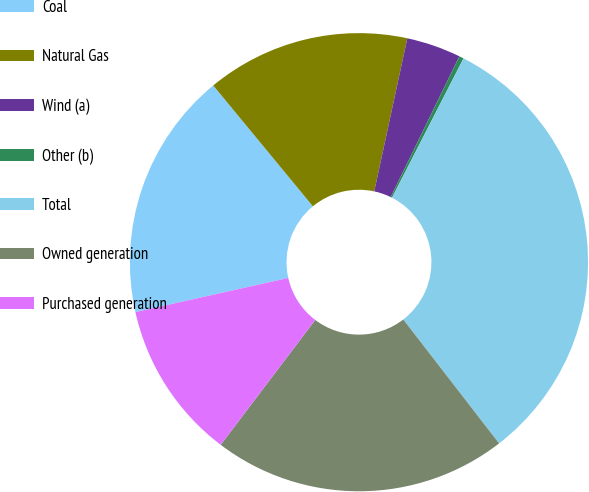<chart> <loc_0><loc_0><loc_500><loc_500><pie_chart><fcel>Coal<fcel>Natural Gas<fcel>Wind (a)<fcel>Other (b)<fcel>Total<fcel>Owned generation<fcel>Purchased generation<nl><fcel>17.52%<fcel>14.36%<fcel>3.84%<fcel>0.32%<fcel>31.98%<fcel>20.79%<fcel>11.19%<nl></chart> 